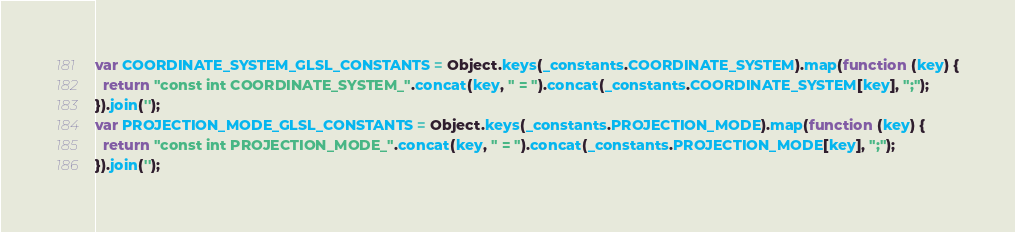Convert code to text. <code><loc_0><loc_0><loc_500><loc_500><_JavaScript_>
var COORDINATE_SYSTEM_GLSL_CONSTANTS = Object.keys(_constants.COORDINATE_SYSTEM).map(function (key) {
  return "const int COORDINATE_SYSTEM_".concat(key, " = ").concat(_constants.COORDINATE_SYSTEM[key], ";");
}).join('');
var PROJECTION_MODE_GLSL_CONSTANTS = Object.keys(_constants.PROJECTION_MODE).map(function (key) {
  return "const int PROJECTION_MODE_".concat(key, " = ").concat(_constants.PROJECTION_MODE[key], ";");
}).join('');
</code> 